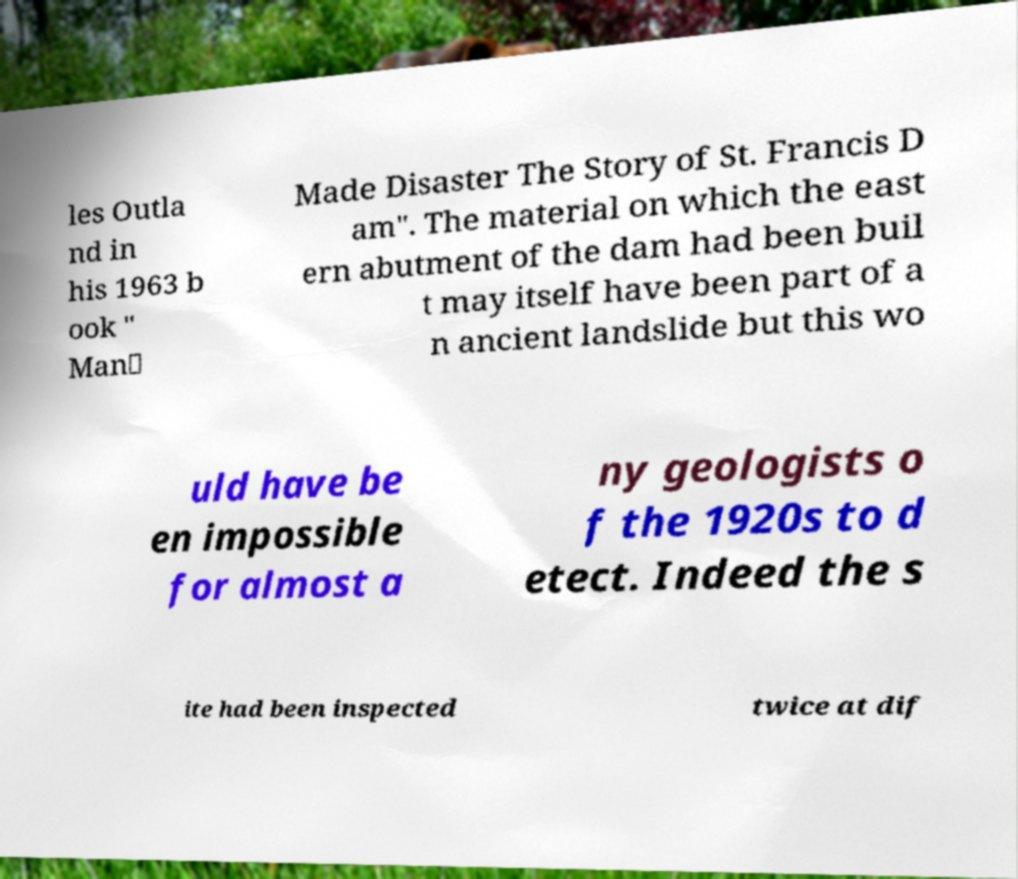Please identify and transcribe the text found in this image. les Outla nd in his 1963 b ook " Man‑ Made Disaster The Story of St. Francis D am". The material on which the east ern abutment of the dam had been buil t may itself have been part of a n ancient landslide but this wo uld have be en impossible for almost a ny geologists o f the 1920s to d etect. Indeed the s ite had been inspected twice at dif 